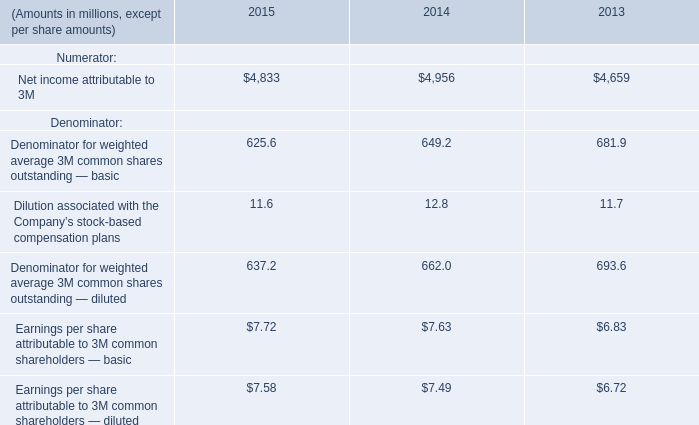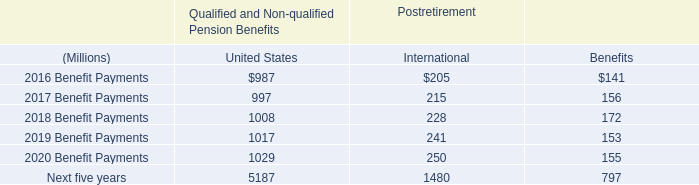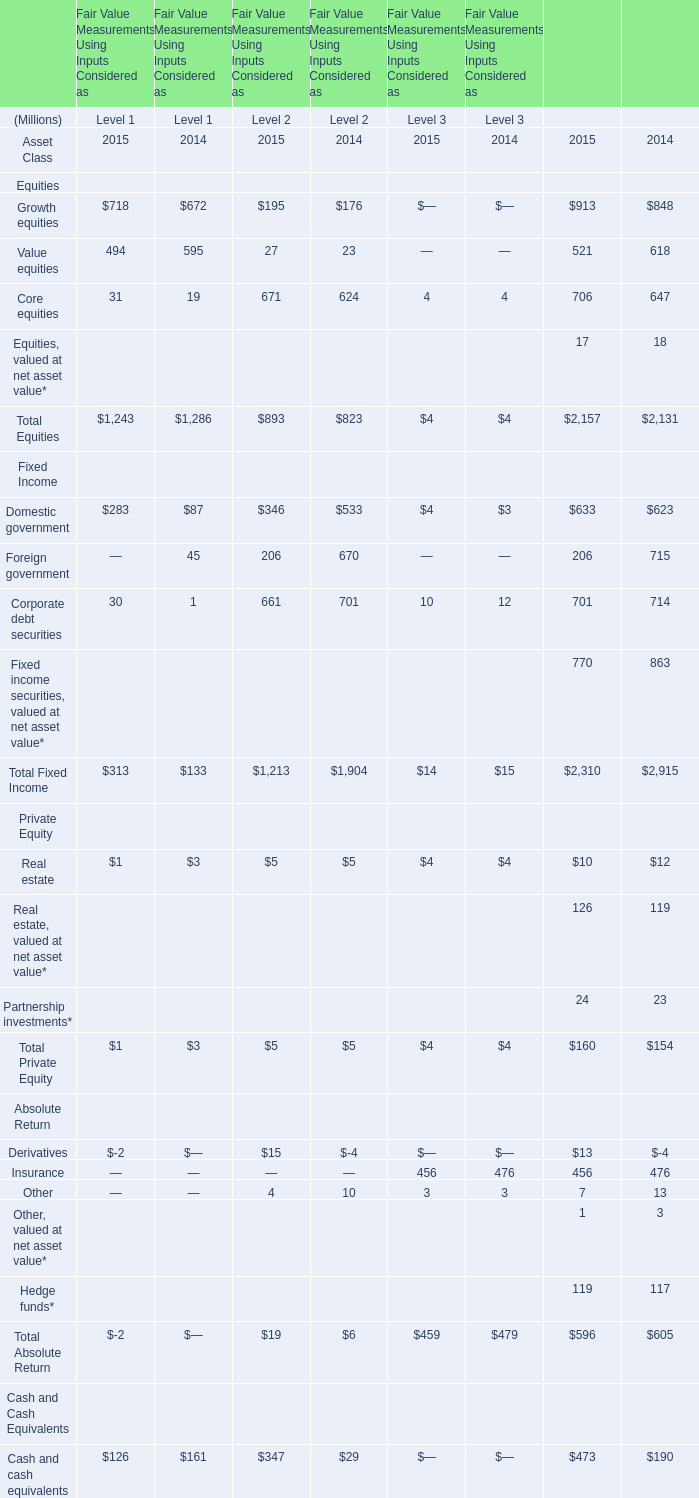Which year is Total Fixed Income of Level 1 larger? 
Answer: 2015. 